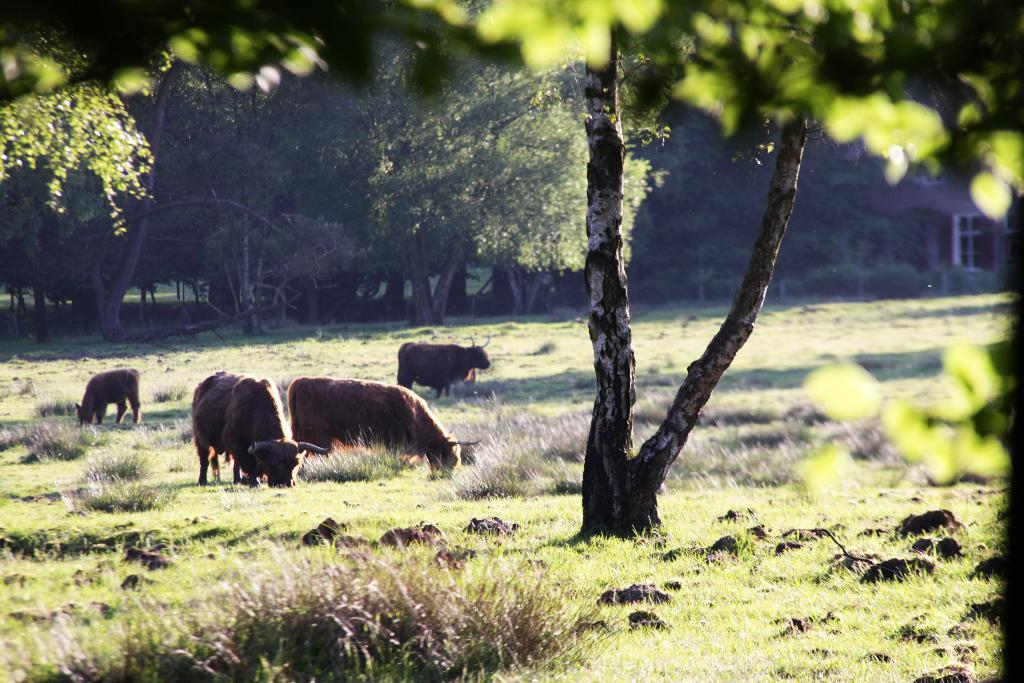What type of living organisms can be seen on the ground in the image? There are animals on the ground in the image. What other natural elements can be seen in the image? There are plants, trees, stones, and grass in the image. What language are the animals speaking in the image? Animals do not speak a language, so this cannot be determined from the image. 